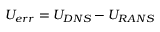<formula> <loc_0><loc_0><loc_500><loc_500>U _ { e r r } = U _ { D N S } - U _ { R A N S }</formula> 